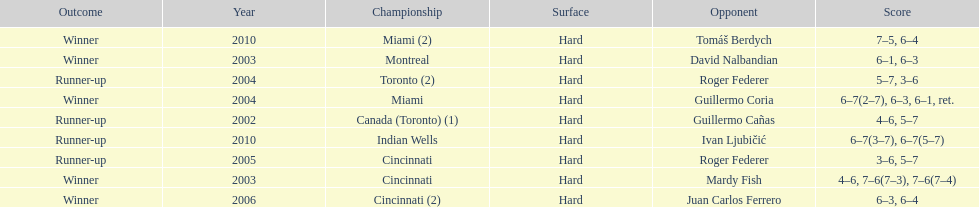Parse the full table. {'header': ['Outcome', 'Year', 'Championship', 'Surface', 'Opponent', 'Score'], 'rows': [['Winner', '2010', 'Miami (2)', 'Hard', 'Tomáš Berdych', '7–5, 6–4'], ['Winner', '2003', 'Montreal', 'Hard', 'David Nalbandian', '6–1, 6–3'], ['Runner-up', '2004', 'Toronto (2)', 'Hard', 'Roger Federer', '5–7, 3–6'], ['Winner', '2004', 'Miami', 'Hard', 'Guillermo Coria', '6–7(2–7), 6–3, 6–1, ret.'], ['Runner-up', '2002', 'Canada (Toronto) (1)', 'Hard', 'Guillermo Cañas', '4–6, 5–7'], ['Runner-up', '2010', 'Indian Wells', 'Hard', 'Ivan Ljubičić', '6–7(3–7), 6–7(5–7)'], ['Runner-up', '2005', 'Cincinnati', 'Hard', 'Roger Federer', '3–6, 5–7'], ['Winner', '2003', 'Cincinnati', 'Hard', 'Mardy Fish', '4–6, 7–6(7–3), 7–6(7–4)'], ['Winner', '2006', 'Cincinnati (2)', 'Hard', 'Juan Carlos Ferrero', '6–3, 6–4']]} Was roddick a runner-up or winner more? Winner. 